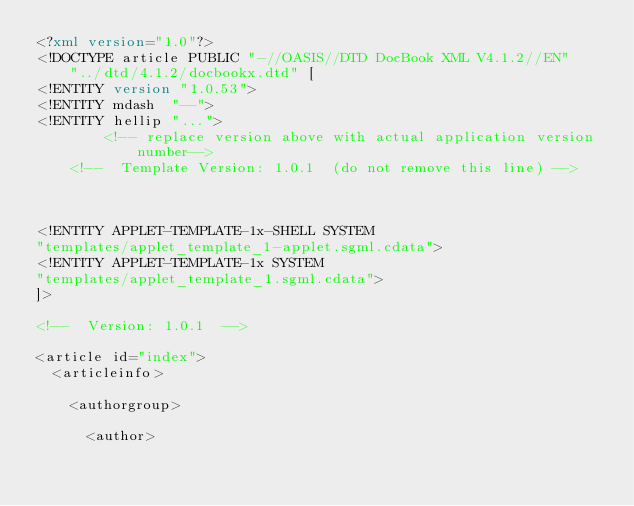<code> <loc_0><loc_0><loc_500><loc_500><_XML_><?xml version="1.0"?>
<!DOCTYPE article PUBLIC "-//OASIS//DTD DocBook XML V4.1.2//EN"
    "../dtd/4.1.2/docbookx.dtd" [
<!ENTITY version "1.0.53">
<!ENTITY mdash  "--">
<!ENTITY hellip "...">
        <!-- replace version above with actual application version number-->
	<!--  Template Version: 1.0.1  (do not remove this line) -->



<!ENTITY APPLET-TEMPLATE-1x-SHELL SYSTEM
"templates/applet_template_1-applet.sgml.cdata">
<!ENTITY APPLET-TEMPLATE-1x SYSTEM
"templates/applet_template_1.sgml.cdata">
]>

<!--  Version: 1.0.1  -->

<article id="index">
  <articleinfo>

    <authorgroup>

      <author></code> 